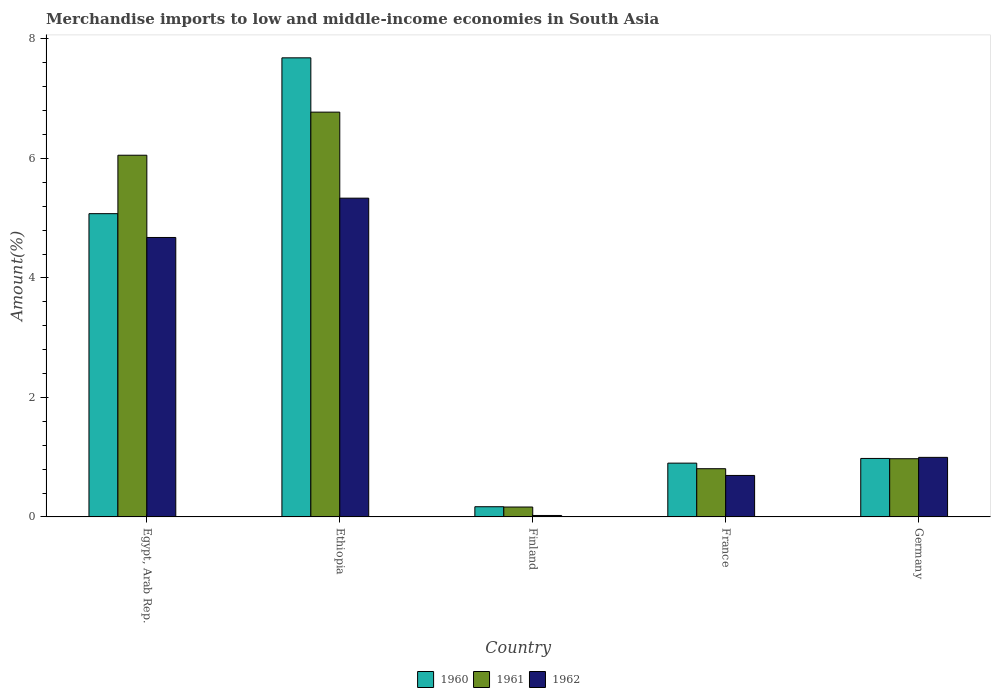How many groups of bars are there?
Your answer should be compact. 5. Are the number of bars per tick equal to the number of legend labels?
Offer a terse response. Yes. How many bars are there on the 3rd tick from the right?
Ensure brevity in your answer.  3. What is the label of the 2nd group of bars from the left?
Your response must be concise. Ethiopia. What is the percentage of amount earned from merchandise imports in 1960 in Egypt, Arab Rep.?
Make the answer very short. 5.08. Across all countries, what is the maximum percentage of amount earned from merchandise imports in 1962?
Offer a terse response. 5.33. Across all countries, what is the minimum percentage of amount earned from merchandise imports in 1961?
Provide a succinct answer. 0.17. In which country was the percentage of amount earned from merchandise imports in 1962 maximum?
Your answer should be very brief. Ethiopia. In which country was the percentage of amount earned from merchandise imports in 1960 minimum?
Your answer should be very brief. Finland. What is the total percentage of amount earned from merchandise imports in 1962 in the graph?
Your answer should be compact. 11.73. What is the difference between the percentage of amount earned from merchandise imports in 1960 in Ethiopia and that in France?
Your answer should be very brief. 6.78. What is the difference between the percentage of amount earned from merchandise imports in 1961 in France and the percentage of amount earned from merchandise imports in 1960 in Finland?
Offer a very short reply. 0.64. What is the average percentage of amount earned from merchandise imports in 1960 per country?
Ensure brevity in your answer.  2.96. What is the difference between the percentage of amount earned from merchandise imports of/in 1961 and percentage of amount earned from merchandise imports of/in 1960 in Egypt, Arab Rep.?
Your answer should be very brief. 0.98. What is the ratio of the percentage of amount earned from merchandise imports in 1961 in Egypt, Arab Rep. to that in France?
Ensure brevity in your answer.  7.5. Is the percentage of amount earned from merchandise imports in 1962 in Egypt, Arab Rep. less than that in Germany?
Make the answer very short. No. What is the difference between the highest and the second highest percentage of amount earned from merchandise imports in 1962?
Make the answer very short. -3.68. What is the difference between the highest and the lowest percentage of amount earned from merchandise imports in 1961?
Provide a short and direct response. 6.61. Is it the case that in every country, the sum of the percentage of amount earned from merchandise imports in 1962 and percentage of amount earned from merchandise imports in 1960 is greater than the percentage of amount earned from merchandise imports in 1961?
Provide a short and direct response. Yes. Are all the bars in the graph horizontal?
Give a very brief answer. No. Are the values on the major ticks of Y-axis written in scientific E-notation?
Your answer should be very brief. No. Does the graph contain grids?
Provide a succinct answer. No. Where does the legend appear in the graph?
Ensure brevity in your answer.  Bottom center. How many legend labels are there?
Your response must be concise. 3. How are the legend labels stacked?
Offer a terse response. Horizontal. What is the title of the graph?
Make the answer very short. Merchandise imports to low and middle-income economies in South Asia. Does "2015" appear as one of the legend labels in the graph?
Give a very brief answer. No. What is the label or title of the Y-axis?
Make the answer very short. Amount(%). What is the Amount(%) in 1960 in Egypt, Arab Rep.?
Provide a succinct answer. 5.08. What is the Amount(%) in 1961 in Egypt, Arab Rep.?
Your answer should be very brief. 6.05. What is the Amount(%) of 1962 in Egypt, Arab Rep.?
Ensure brevity in your answer.  4.68. What is the Amount(%) of 1960 in Ethiopia?
Your answer should be very brief. 7.68. What is the Amount(%) in 1961 in Ethiopia?
Make the answer very short. 6.77. What is the Amount(%) of 1962 in Ethiopia?
Your response must be concise. 5.33. What is the Amount(%) in 1960 in Finland?
Offer a very short reply. 0.17. What is the Amount(%) of 1961 in Finland?
Your answer should be compact. 0.17. What is the Amount(%) in 1962 in Finland?
Give a very brief answer. 0.02. What is the Amount(%) of 1960 in France?
Your answer should be compact. 0.9. What is the Amount(%) in 1961 in France?
Provide a succinct answer. 0.81. What is the Amount(%) in 1962 in France?
Ensure brevity in your answer.  0.69. What is the Amount(%) in 1960 in Germany?
Make the answer very short. 0.98. What is the Amount(%) of 1961 in Germany?
Offer a terse response. 0.97. What is the Amount(%) of 1962 in Germany?
Your answer should be compact. 1. Across all countries, what is the maximum Amount(%) in 1960?
Make the answer very short. 7.68. Across all countries, what is the maximum Amount(%) of 1961?
Your response must be concise. 6.77. Across all countries, what is the maximum Amount(%) of 1962?
Keep it short and to the point. 5.33. Across all countries, what is the minimum Amount(%) in 1960?
Your answer should be very brief. 0.17. Across all countries, what is the minimum Amount(%) of 1961?
Provide a short and direct response. 0.17. Across all countries, what is the minimum Amount(%) in 1962?
Ensure brevity in your answer.  0.02. What is the total Amount(%) in 1960 in the graph?
Give a very brief answer. 14.81. What is the total Amount(%) of 1961 in the graph?
Your answer should be very brief. 14.77. What is the total Amount(%) of 1962 in the graph?
Provide a short and direct response. 11.73. What is the difference between the Amount(%) of 1960 in Egypt, Arab Rep. and that in Ethiopia?
Offer a terse response. -2.61. What is the difference between the Amount(%) of 1961 in Egypt, Arab Rep. and that in Ethiopia?
Your answer should be very brief. -0.72. What is the difference between the Amount(%) of 1962 in Egypt, Arab Rep. and that in Ethiopia?
Offer a very short reply. -0.66. What is the difference between the Amount(%) in 1960 in Egypt, Arab Rep. and that in Finland?
Provide a succinct answer. 4.9. What is the difference between the Amount(%) of 1961 in Egypt, Arab Rep. and that in Finland?
Offer a very short reply. 5.89. What is the difference between the Amount(%) of 1962 in Egypt, Arab Rep. and that in Finland?
Offer a very short reply. 4.65. What is the difference between the Amount(%) in 1960 in Egypt, Arab Rep. and that in France?
Offer a terse response. 4.18. What is the difference between the Amount(%) in 1961 in Egypt, Arab Rep. and that in France?
Make the answer very short. 5.25. What is the difference between the Amount(%) in 1962 in Egypt, Arab Rep. and that in France?
Give a very brief answer. 3.98. What is the difference between the Amount(%) of 1960 in Egypt, Arab Rep. and that in Germany?
Your answer should be very brief. 4.1. What is the difference between the Amount(%) in 1961 in Egypt, Arab Rep. and that in Germany?
Offer a very short reply. 5.08. What is the difference between the Amount(%) in 1962 in Egypt, Arab Rep. and that in Germany?
Keep it short and to the point. 3.68. What is the difference between the Amount(%) in 1960 in Ethiopia and that in Finland?
Your answer should be very brief. 7.51. What is the difference between the Amount(%) of 1961 in Ethiopia and that in Finland?
Provide a succinct answer. 6.61. What is the difference between the Amount(%) of 1962 in Ethiopia and that in Finland?
Keep it short and to the point. 5.31. What is the difference between the Amount(%) of 1960 in Ethiopia and that in France?
Your answer should be very brief. 6.78. What is the difference between the Amount(%) of 1961 in Ethiopia and that in France?
Make the answer very short. 5.97. What is the difference between the Amount(%) in 1962 in Ethiopia and that in France?
Ensure brevity in your answer.  4.64. What is the difference between the Amount(%) in 1960 in Ethiopia and that in Germany?
Provide a short and direct response. 6.7. What is the difference between the Amount(%) of 1961 in Ethiopia and that in Germany?
Your answer should be very brief. 5.8. What is the difference between the Amount(%) in 1962 in Ethiopia and that in Germany?
Make the answer very short. 4.34. What is the difference between the Amount(%) in 1960 in Finland and that in France?
Your answer should be compact. -0.73. What is the difference between the Amount(%) of 1961 in Finland and that in France?
Ensure brevity in your answer.  -0.64. What is the difference between the Amount(%) in 1962 in Finland and that in France?
Provide a short and direct response. -0.67. What is the difference between the Amount(%) of 1960 in Finland and that in Germany?
Make the answer very short. -0.81. What is the difference between the Amount(%) in 1961 in Finland and that in Germany?
Offer a very short reply. -0.81. What is the difference between the Amount(%) in 1962 in Finland and that in Germany?
Provide a succinct answer. -0.97. What is the difference between the Amount(%) of 1960 in France and that in Germany?
Keep it short and to the point. -0.08. What is the difference between the Amount(%) in 1961 in France and that in Germany?
Your answer should be very brief. -0.17. What is the difference between the Amount(%) in 1962 in France and that in Germany?
Your answer should be compact. -0.3. What is the difference between the Amount(%) in 1960 in Egypt, Arab Rep. and the Amount(%) in 1961 in Ethiopia?
Your answer should be compact. -1.7. What is the difference between the Amount(%) of 1960 in Egypt, Arab Rep. and the Amount(%) of 1962 in Ethiopia?
Keep it short and to the point. -0.26. What is the difference between the Amount(%) of 1961 in Egypt, Arab Rep. and the Amount(%) of 1962 in Ethiopia?
Your answer should be very brief. 0.72. What is the difference between the Amount(%) of 1960 in Egypt, Arab Rep. and the Amount(%) of 1961 in Finland?
Give a very brief answer. 4.91. What is the difference between the Amount(%) in 1960 in Egypt, Arab Rep. and the Amount(%) in 1962 in Finland?
Your answer should be very brief. 5.05. What is the difference between the Amount(%) of 1961 in Egypt, Arab Rep. and the Amount(%) of 1962 in Finland?
Your answer should be very brief. 6.03. What is the difference between the Amount(%) of 1960 in Egypt, Arab Rep. and the Amount(%) of 1961 in France?
Your answer should be compact. 4.27. What is the difference between the Amount(%) of 1960 in Egypt, Arab Rep. and the Amount(%) of 1962 in France?
Make the answer very short. 4.38. What is the difference between the Amount(%) in 1961 in Egypt, Arab Rep. and the Amount(%) in 1962 in France?
Ensure brevity in your answer.  5.36. What is the difference between the Amount(%) in 1960 in Egypt, Arab Rep. and the Amount(%) in 1961 in Germany?
Your answer should be very brief. 4.1. What is the difference between the Amount(%) in 1960 in Egypt, Arab Rep. and the Amount(%) in 1962 in Germany?
Your response must be concise. 4.08. What is the difference between the Amount(%) in 1961 in Egypt, Arab Rep. and the Amount(%) in 1962 in Germany?
Provide a short and direct response. 5.06. What is the difference between the Amount(%) of 1960 in Ethiopia and the Amount(%) of 1961 in Finland?
Ensure brevity in your answer.  7.52. What is the difference between the Amount(%) in 1960 in Ethiopia and the Amount(%) in 1962 in Finland?
Your response must be concise. 7.66. What is the difference between the Amount(%) in 1961 in Ethiopia and the Amount(%) in 1962 in Finland?
Provide a succinct answer. 6.75. What is the difference between the Amount(%) of 1960 in Ethiopia and the Amount(%) of 1961 in France?
Provide a short and direct response. 6.88. What is the difference between the Amount(%) in 1960 in Ethiopia and the Amount(%) in 1962 in France?
Your answer should be compact. 6.99. What is the difference between the Amount(%) in 1961 in Ethiopia and the Amount(%) in 1962 in France?
Make the answer very short. 6.08. What is the difference between the Amount(%) of 1960 in Ethiopia and the Amount(%) of 1961 in Germany?
Provide a succinct answer. 6.71. What is the difference between the Amount(%) of 1960 in Ethiopia and the Amount(%) of 1962 in Germany?
Offer a very short reply. 6.69. What is the difference between the Amount(%) in 1961 in Ethiopia and the Amount(%) in 1962 in Germany?
Provide a succinct answer. 5.78. What is the difference between the Amount(%) of 1960 in Finland and the Amount(%) of 1961 in France?
Make the answer very short. -0.64. What is the difference between the Amount(%) in 1960 in Finland and the Amount(%) in 1962 in France?
Offer a very short reply. -0.52. What is the difference between the Amount(%) in 1961 in Finland and the Amount(%) in 1962 in France?
Your answer should be compact. -0.53. What is the difference between the Amount(%) in 1960 in Finland and the Amount(%) in 1961 in Germany?
Offer a terse response. -0.8. What is the difference between the Amount(%) in 1960 in Finland and the Amount(%) in 1962 in Germany?
Keep it short and to the point. -0.83. What is the difference between the Amount(%) of 1961 in Finland and the Amount(%) of 1962 in Germany?
Keep it short and to the point. -0.83. What is the difference between the Amount(%) of 1960 in France and the Amount(%) of 1961 in Germany?
Give a very brief answer. -0.07. What is the difference between the Amount(%) of 1960 in France and the Amount(%) of 1962 in Germany?
Your answer should be very brief. -0.1. What is the difference between the Amount(%) of 1961 in France and the Amount(%) of 1962 in Germany?
Your response must be concise. -0.19. What is the average Amount(%) of 1960 per country?
Ensure brevity in your answer.  2.96. What is the average Amount(%) in 1961 per country?
Give a very brief answer. 2.95. What is the average Amount(%) of 1962 per country?
Provide a short and direct response. 2.35. What is the difference between the Amount(%) in 1960 and Amount(%) in 1961 in Egypt, Arab Rep.?
Your answer should be very brief. -0.98. What is the difference between the Amount(%) of 1960 and Amount(%) of 1962 in Egypt, Arab Rep.?
Your answer should be compact. 0.4. What is the difference between the Amount(%) of 1961 and Amount(%) of 1962 in Egypt, Arab Rep.?
Offer a terse response. 1.38. What is the difference between the Amount(%) in 1960 and Amount(%) in 1961 in Ethiopia?
Your response must be concise. 0.91. What is the difference between the Amount(%) of 1960 and Amount(%) of 1962 in Ethiopia?
Provide a short and direct response. 2.35. What is the difference between the Amount(%) in 1961 and Amount(%) in 1962 in Ethiopia?
Provide a short and direct response. 1.44. What is the difference between the Amount(%) of 1960 and Amount(%) of 1961 in Finland?
Keep it short and to the point. 0.01. What is the difference between the Amount(%) in 1960 and Amount(%) in 1962 in Finland?
Keep it short and to the point. 0.15. What is the difference between the Amount(%) of 1961 and Amount(%) of 1962 in Finland?
Your answer should be compact. 0.14. What is the difference between the Amount(%) of 1960 and Amount(%) of 1961 in France?
Offer a terse response. 0.09. What is the difference between the Amount(%) in 1960 and Amount(%) in 1962 in France?
Ensure brevity in your answer.  0.21. What is the difference between the Amount(%) in 1961 and Amount(%) in 1962 in France?
Give a very brief answer. 0.11. What is the difference between the Amount(%) in 1960 and Amount(%) in 1961 in Germany?
Give a very brief answer. 0. What is the difference between the Amount(%) of 1960 and Amount(%) of 1962 in Germany?
Provide a succinct answer. -0.02. What is the difference between the Amount(%) of 1961 and Amount(%) of 1962 in Germany?
Provide a short and direct response. -0.02. What is the ratio of the Amount(%) of 1960 in Egypt, Arab Rep. to that in Ethiopia?
Ensure brevity in your answer.  0.66. What is the ratio of the Amount(%) of 1961 in Egypt, Arab Rep. to that in Ethiopia?
Provide a short and direct response. 0.89. What is the ratio of the Amount(%) of 1962 in Egypt, Arab Rep. to that in Ethiopia?
Your response must be concise. 0.88. What is the ratio of the Amount(%) in 1960 in Egypt, Arab Rep. to that in Finland?
Your answer should be very brief. 29.72. What is the ratio of the Amount(%) of 1961 in Egypt, Arab Rep. to that in Finland?
Ensure brevity in your answer.  36.5. What is the ratio of the Amount(%) of 1962 in Egypt, Arab Rep. to that in Finland?
Your answer should be compact. 191.4. What is the ratio of the Amount(%) in 1960 in Egypt, Arab Rep. to that in France?
Your response must be concise. 5.64. What is the ratio of the Amount(%) in 1961 in Egypt, Arab Rep. to that in France?
Make the answer very short. 7.5. What is the ratio of the Amount(%) of 1962 in Egypt, Arab Rep. to that in France?
Your answer should be compact. 6.74. What is the ratio of the Amount(%) in 1960 in Egypt, Arab Rep. to that in Germany?
Keep it short and to the point. 5.19. What is the ratio of the Amount(%) in 1961 in Egypt, Arab Rep. to that in Germany?
Your answer should be very brief. 6.21. What is the ratio of the Amount(%) of 1962 in Egypt, Arab Rep. to that in Germany?
Give a very brief answer. 4.69. What is the ratio of the Amount(%) in 1960 in Ethiopia to that in Finland?
Your response must be concise. 44.98. What is the ratio of the Amount(%) in 1961 in Ethiopia to that in Finland?
Your response must be concise. 40.85. What is the ratio of the Amount(%) of 1962 in Ethiopia to that in Finland?
Offer a terse response. 218.33. What is the ratio of the Amount(%) of 1960 in Ethiopia to that in France?
Keep it short and to the point. 8.54. What is the ratio of the Amount(%) of 1961 in Ethiopia to that in France?
Your answer should be compact. 8.4. What is the ratio of the Amount(%) of 1962 in Ethiopia to that in France?
Ensure brevity in your answer.  7.68. What is the ratio of the Amount(%) in 1960 in Ethiopia to that in Germany?
Keep it short and to the point. 7.85. What is the ratio of the Amount(%) of 1961 in Ethiopia to that in Germany?
Your answer should be very brief. 6.95. What is the ratio of the Amount(%) in 1962 in Ethiopia to that in Germany?
Offer a terse response. 5.35. What is the ratio of the Amount(%) of 1960 in Finland to that in France?
Provide a succinct answer. 0.19. What is the ratio of the Amount(%) of 1961 in Finland to that in France?
Offer a very short reply. 0.21. What is the ratio of the Amount(%) of 1962 in Finland to that in France?
Your answer should be very brief. 0.04. What is the ratio of the Amount(%) in 1960 in Finland to that in Germany?
Your answer should be compact. 0.17. What is the ratio of the Amount(%) of 1961 in Finland to that in Germany?
Offer a very short reply. 0.17. What is the ratio of the Amount(%) in 1962 in Finland to that in Germany?
Offer a very short reply. 0.02. What is the ratio of the Amount(%) in 1960 in France to that in Germany?
Make the answer very short. 0.92. What is the ratio of the Amount(%) of 1961 in France to that in Germany?
Offer a terse response. 0.83. What is the ratio of the Amount(%) of 1962 in France to that in Germany?
Keep it short and to the point. 0.7. What is the difference between the highest and the second highest Amount(%) in 1960?
Provide a short and direct response. 2.61. What is the difference between the highest and the second highest Amount(%) of 1961?
Your response must be concise. 0.72. What is the difference between the highest and the second highest Amount(%) of 1962?
Give a very brief answer. 0.66. What is the difference between the highest and the lowest Amount(%) of 1960?
Provide a short and direct response. 7.51. What is the difference between the highest and the lowest Amount(%) in 1961?
Your response must be concise. 6.61. What is the difference between the highest and the lowest Amount(%) of 1962?
Your response must be concise. 5.31. 